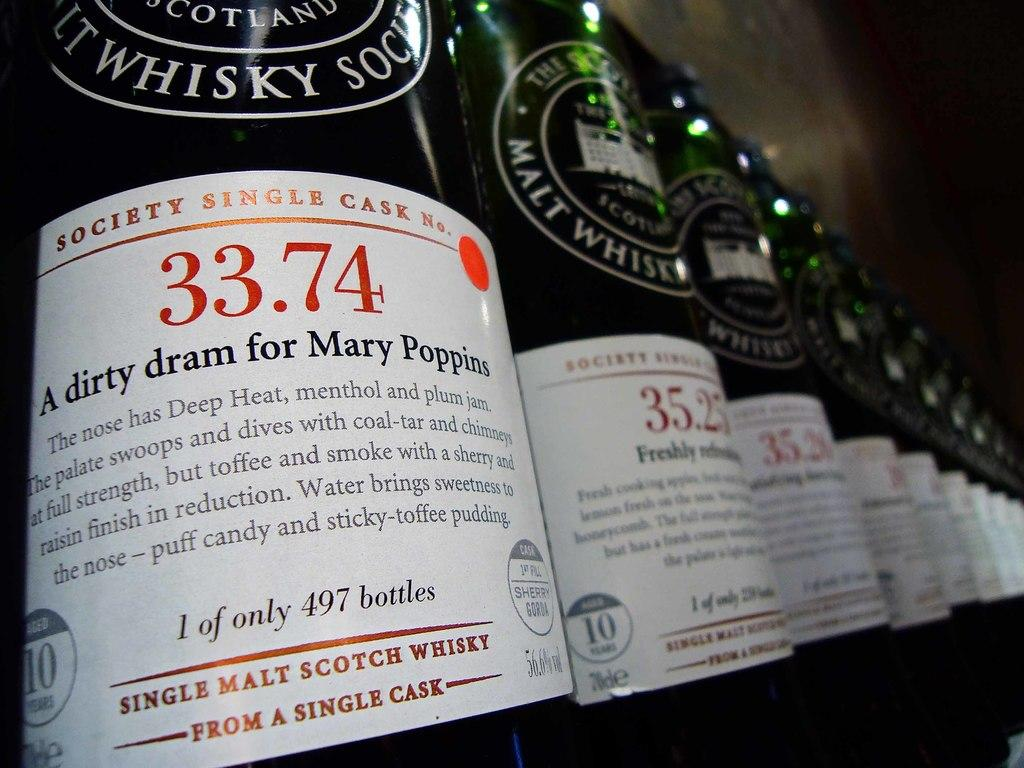<image>
Describe the image concisely. A row of Single Malt Scotch whisky bottles 